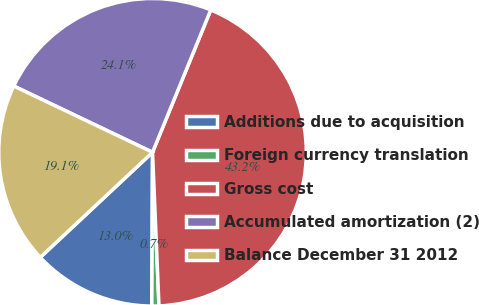Convert chart to OTSL. <chart><loc_0><loc_0><loc_500><loc_500><pie_chart><fcel>Additions due to acquisition<fcel>Foreign currency translation<fcel>Gross cost<fcel>Accumulated amortization (2)<fcel>Balance December 31 2012<nl><fcel>12.95%<fcel>0.74%<fcel>43.15%<fcel>24.09%<fcel>19.06%<nl></chart> 